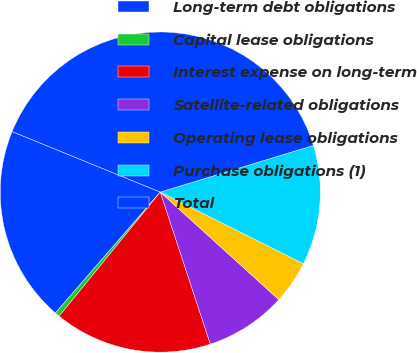Convert chart to OTSL. <chart><loc_0><loc_0><loc_500><loc_500><pie_chart><fcel>Long-term debt obligations<fcel>Capital lease obligations<fcel>Interest expense on long-term<fcel>Satellite-related obligations<fcel>Operating lease obligations<fcel>Purchase obligations (1)<fcel>Total<nl><fcel>19.8%<fcel>0.49%<fcel>15.94%<fcel>8.21%<fcel>4.35%<fcel>12.08%<fcel>39.12%<nl></chart> 